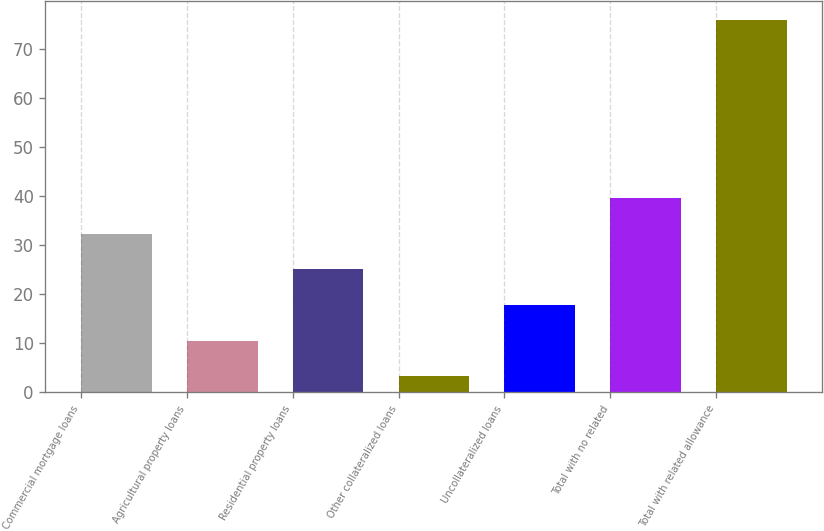Convert chart. <chart><loc_0><loc_0><loc_500><loc_500><bar_chart><fcel>Commercial mortgage loans<fcel>Agricultural property loans<fcel>Residential property loans<fcel>Other collateralized loans<fcel>Uncollateralized loans<fcel>Total with no related<fcel>Total with related allowance<nl><fcel>32.35<fcel>10.51<fcel>25.07<fcel>3.23<fcel>17.79<fcel>39.63<fcel>76<nl></chart> 